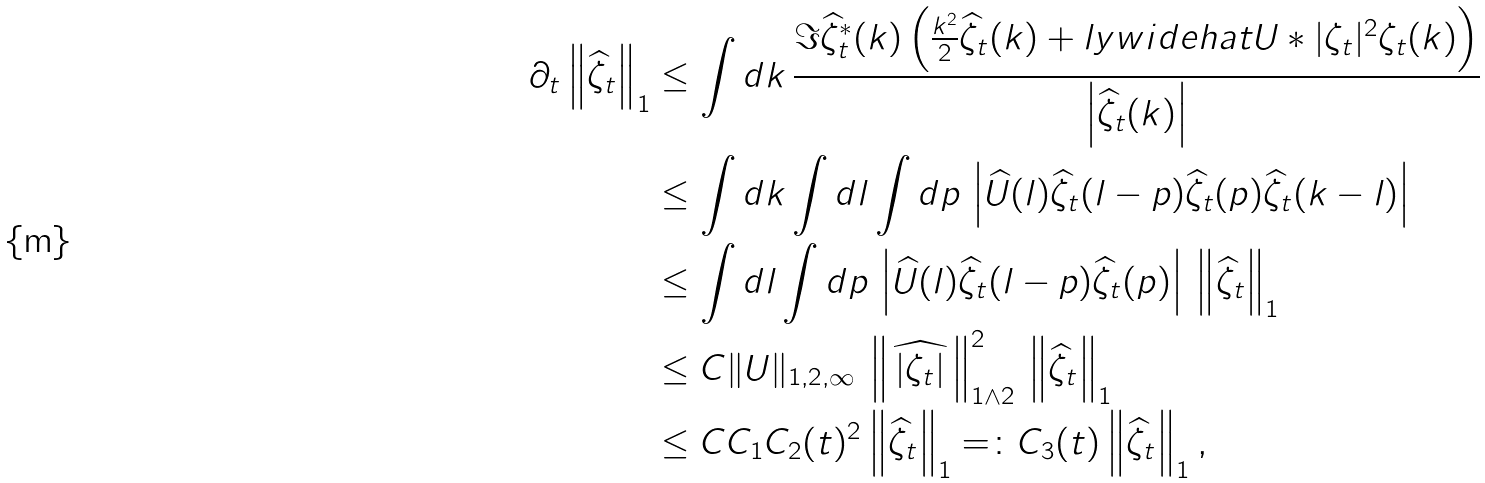<formula> <loc_0><loc_0><loc_500><loc_500>\partial _ { t } \left \| \widehat { \zeta } _ { t } \right \| _ { 1 } & \leq \int d k \, \frac { \Im \widehat { \zeta } ^ { * } _ { t } ( k ) \left ( \frac { k ^ { 2 } } { 2 } \widehat { \zeta } _ { t } ( k ) + \real l y w i d e h a t { U * | \zeta _ { t } | ^ { 2 } \zeta _ { t } } ( k ) \right ) } { \left | \widehat { \zeta } _ { t } ( k ) \right | } \\ & \leq \int d k \int d l \int d p \, \left | \widehat { U } ( l ) \widehat { \zeta } _ { t } ( l - p ) \widehat { \zeta } _ { t } ( p ) \widehat { \zeta } _ { t } ( k - l ) \right | \\ & \leq \int d l \int d p \, \left | \widehat { U } ( l ) \widehat { \zeta } _ { t } ( l - p ) \widehat { \zeta } _ { t } ( p ) \right | \, \left \| \widehat { \zeta } _ { t } \right \| _ { 1 } \\ & \leq C \| U \| _ { 1 , 2 , \infty } \, \left \| \widehat { \, | \zeta _ { t } | \, } \right \| _ { 1 \wedge 2 } ^ { 2 } \, \left \| \widehat { \zeta } _ { t } \right \| _ { 1 } \\ & \leq C C _ { 1 } C _ { 2 } ( t ) ^ { 2 } \left \| \widehat { \zeta } _ { t } \right \| _ { 1 } = \colon C _ { 3 } ( t ) \left \| \widehat { \zeta } _ { t } \right \| _ { 1 } ,</formula> 